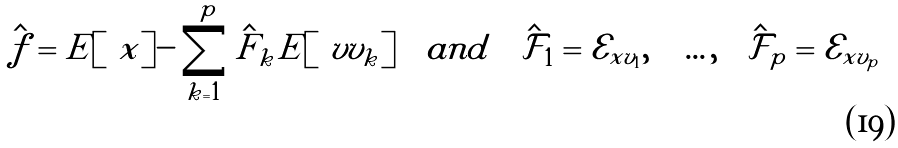<formula> <loc_0><loc_0><loc_500><loc_500>\hat { f } = E [ \ x ] - \sum _ { k = 1 } ^ { p } \hat { F } _ { k } E [ \ v v _ { k } ] \quad a n d \quad \hat { \mathcal { F } } _ { 1 } = { \mathcal { E } } _ { x v _ { 1 } } , \quad \dots , \quad \hat { \mathcal { F } } _ { p } = { \mathcal { E } } _ { x v _ { p } }</formula> 